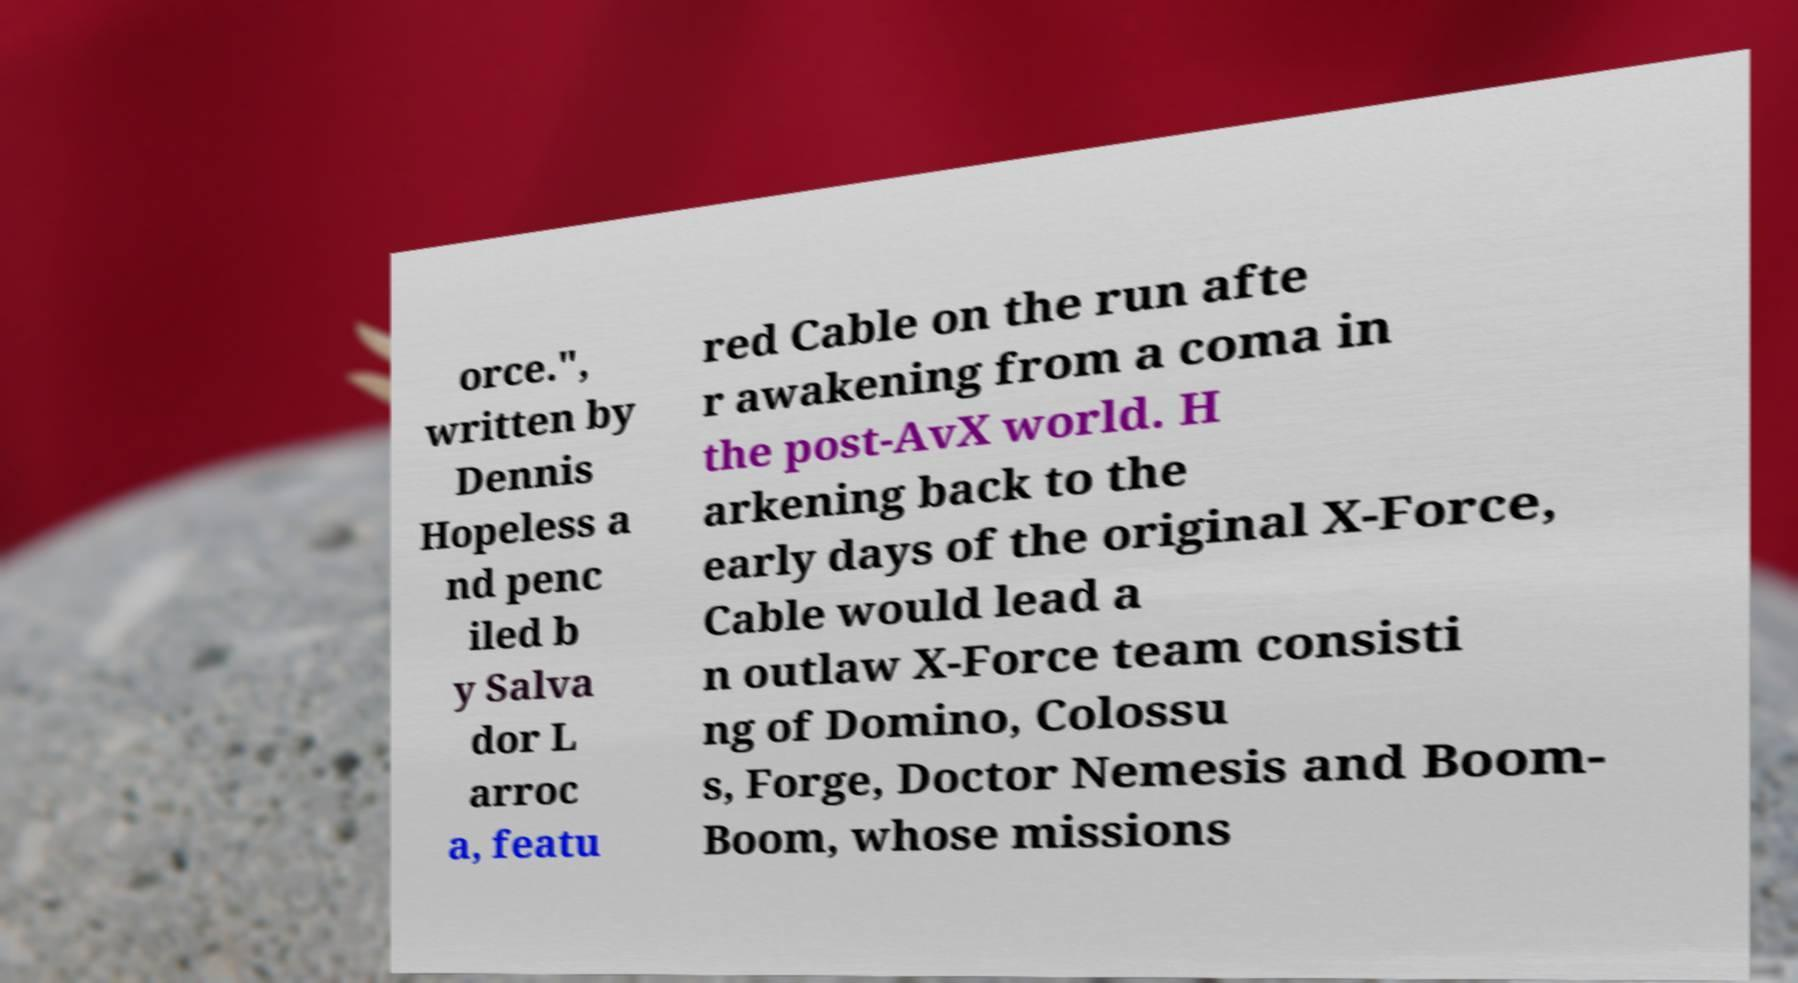Could you extract and type out the text from this image? orce.", written by Dennis Hopeless a nd penc iled b y Salva dor L arroc a, featu red Cable on the run afte r awakening from a coma in the post-AvX world. H arkening back to the early days of the original X-Force, Cable would lead a n outlaw X-Force team consisti ng of Domino, Colossu s, Forge, Doctor Nemesis and Boom- Boom, whose missions 